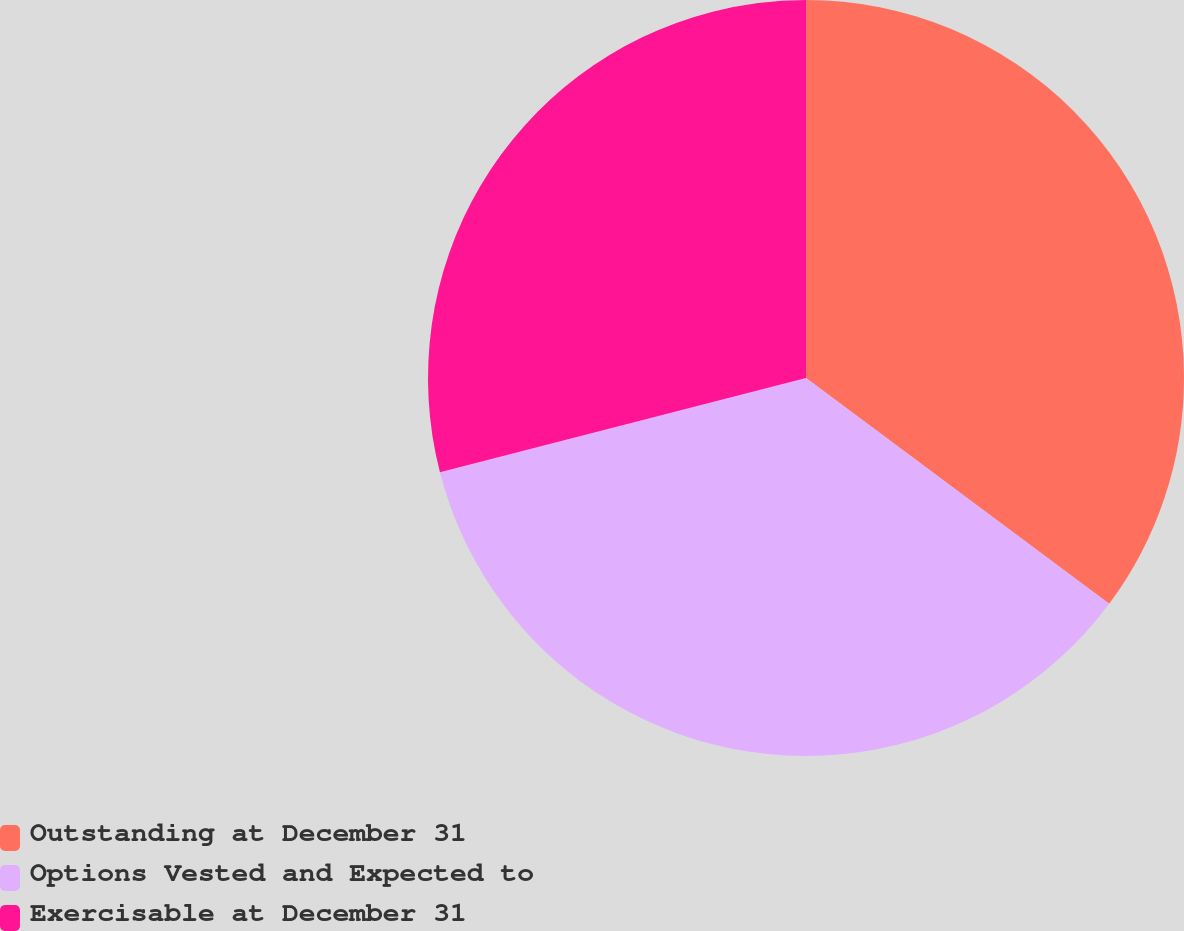Convert chart. <chart><loc_0><loc_0><loc_500><loc_500><pie_chart><fcel>Outstanding at December 31<fcel>Options Vested and Expected to<fcel>Exercisable at December 31<nl><fcel>35.19%<fcel>35.8%<fcel>29.01%<nl></chart> 